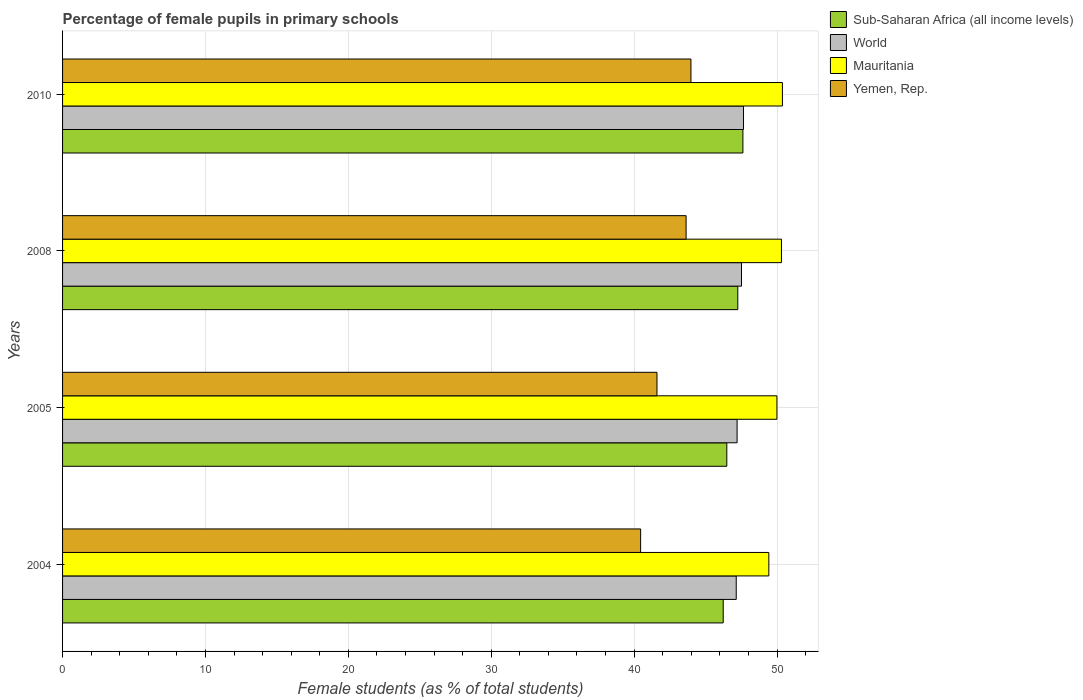How many groups of bars are there?
Provide a succinct answer. 4. Are the number of bars per tick equal to the number of legend labels?
Ensure brevity in your answer.  Yes. Are the number of bars on each tick of the Y-axis equal?
Provide a short and direct response. Yes. How many bars are there on the 2nd tick from the bottom?
Provide a succinct answer. 4. In how many cases, is the number of bars for a given year not equal to the number of legend labels?
Ensure brevity in your answer.  0. What is the percentage of female pupils in primary schools in Mauritania in 2008?
Keep it short and to the point. 50.31. Across all years, what is the maximum percentage of female pupils in primary schools in Mauritania?
Keep it short and to the point. 50.38. Across all years, what is the minimum percentage of female pupils in primary schools in Mauritania?
Give a very brief answer. 49.43. In which year was the percentage of female pupils in primary schools in Yemen, Rep. minimum?
Your response must be concise. 2004. What is the total percentage of female pupils in primary schools in Yemen, Rep. in the graph?
Ensure brevity in your answer.  169.67. What is the difference between the percentage of female pupils in primary schools in Yemen, Rep. in 2005 and that in 2010?
Keep it short and to the point. -2.38. What is the difference between the percentage of female pupils in primary schools in Sub-Saharan Africa (all income levels) in 2004 and the percentage of female pupils in primary schools in World in 2005?
Give a very brief answer. -0.97. What is the average percentage of female pupils in primary schools in World per year?
Your response must be concise. 47.38. In the year 2008, what is the difference between the percentage of female pupils in primary schools in Yemen, Rep. and percentage of female pupils in primary schools in Mauritania?
Offer a terse response. -6.67. What is the ratio of the percentage of female pupils in primary schools in Mauritania in 2004 to that in 2010?
Give a very brief answer. 0.98. Is the percentage of female pupils in primary schools in Yemen, Rep. in 2005 less than that in 2008?
Make the answer very short. Yes. What is the difference between the highest and the second highest percentage of female pupils in primary schools in Mauritania?
Give a very brief answer. 0.07. What is the difference between the highest and the lowest percentage of female pupils in primary schools in Sub-Saharan Africa (all income levels)?
Your response must be concise. 1.38. What does the 4th bar from the top in 2005 represents?
Your response must be concise. Sub-Saharan Africa (all income levels). What does the 2nd bar from the bottom in 2008 represents?
Provide a succinct answer. World. How many bars are there?
Offer a terse response. 16. How many years are there in the graph?
Offer a very short reply. 4. Are the values on the major ticks of X-axis written in scientific E-notation?
Provide a short and direct response. No. Does the graph contain any zero values?
Provide a short and direct response. No. Does the graph contain grids?
Give a very brief answer. Yes. Where does the legend appear in the graph?
Offer a terse response. Top right. How many legend labels are there?
Your answer should be compact. 4. What is the title of the graph?
Offer a terse response. Percentage of female pupils in primary schools. What is the label or title of the X-axis?
Your response must be concise. Female students (as % of total students). What is the label or title of the Y-axis?
Your answer should be compact. Years. What is the Female students (as % of total students) of Sub-Saharan Africa (all income levels) in 2004?
Your answer should be compact. 46.23. What is the Female students (as % of total students) of World in 2004?
Make the answer very short. 47.15. What is the Female students (as % of total students) of Mauritania in 2004?
Make the answer very short. 49.43. What is the Female students (as % of total students) in Yemen, Rep. in 2004?
Provide a short and direct response. 40.45. What is the Female students (as % of total students) in Sub-Saharan Africa (all income levels) in 2005?
Your response must be concise. 46.49. What is the Female students (as % of total students) in World in 2005?
Keep it short and to the point. 47.21. What is the Female students (as % of total students) of Mauritania in 2005?
Your response must be concise. 49.99. What is the Female students (as % of total students) in Yemen, Rep. in 2005?
Offer a terse response. 41.6. What is the Female students (as % of total students) in Sub-Saharan Africa (all income levels) in 2008?
Provide a succinct answer. 47.26. What is the Female students (as % of total students) of World in 2008?
Offer a terse response. 47.52. What is the Female students (as % of total students) of Mauritania in 2008?
Make the answer very short. 50.31. What is the Female students (as % of total students) of Yemen, Rep. in 2008?
Your answer should be very brief. 43.64. What is the Female students (as % of total students) in Sub-Saharan Africa (all income levels) in 2010?
Provide a short and direct response. 47.61. What is the Female students (as % of total students) of World in 2010?
Offer a very short reply. 47.66. What is the Female students (as % of total students) of Mauritania in 2010?
Ensure brevity in your answer.  50.38. What is the Female students (as % of total students) of Yemen, Rep. in 2010?
Keep it short and to the point. 43.98. Across all years, what is the maximum Female students (as % of total students) of Sub-Saharan Africa (all income levels)?
Your answer should be very brief. 47.61. Across all years, what is the maximum Female students (as % of total students) in World?
Offer a terse response. 47.66. Across all years, what is the maximum Female students (as % of total students) in Mauritania?
Your answer should be compact. 50.38. Across all years, what is the maximum Female students (as % of total students) in Yemen, Rep.?
Keep it short and to the point. 43.98. Across all years, what is the minimum Female students (as % of total students) in Sub-Saharan Africa (all income levels)?
Give a very brief answer. 46.23. Across all years, what is the minimum Female students (as % of total students) of World?
Provide a short and direct response. 47.15. Across all years, what is the minimum Female students (as % of total students) in Mauritania?
Provide a succinct answer. 49.43. Across all years, what is the minimum Female students (as % of total students) in Yemen, Rep.?
Provide a short and direct response. 40.45. What is the total Female students (as % of total students) in Sub-Saharan Africa (all income levels) in the graph?
Keep it short and to the point. 187.59. What is the total Female students (as % of total students) in World in the graph?
Your answer should be compact. 189.52. What is the total Female students (as % of total students) in Mauritania in the graph?
Make the answer very short. 200.11. What is the total Female students (as % of total students) of Yemen, Rep. in the graph?
Keep it short and to the point. 169.67. What is the difference between the Female students (as % of total students) of Sub-Saharan Africa (all income levels) in 2004 and that in 2005?
Your answer should be very brief. -0.25. What is the difference between the Female students (as % of total students) of World in 2004 and that in 2005?
Keep it short and to the point. -0.06. What is the difference between the Female students (as % of total students) of Mauritania in 2004 and that in 2005?
Keep it short and to the point. -0.57. What is the difference between the Female students (as % of total students) of Yemen, Rep. in 2004 and that in 2005?
Offer a very short reply. -1.14. What is the difference between the Female students (as % of total students) of Sub-Saharan Africa (all income levels) in 2004 and that in 2008?
Provide a succinct answer. -1.02. What is the difference between the Female students (as % of total students) in World in 2004 and that in 2008?
Your answer should be very brief. -0.37. What is the difference between the Female students (as % of total students) of Mauritania in 2004 and that in 2008?
Give a very brief answer. -0.88. What is the difference between the Female students (as % of total students) of Yemen, Rep. in 2004 and that in 2008?
Your response must be concise. -3.18. What is the difference between the Female students (as % of total students) in Sub-Saharan Africa (all income levels) in 2004 and that in 2010?
Your response must be concise. -1.38. What is the difference between the Female students (as % of total students) of World in 2004 and that in 2010?
Ensure brevity in your answer.  -0.51. What is the difference between the Female students (as % of total students) of Mauritania in 2004 and that in 2010?
Keep it short and to the point. -0.95. What is the difference between the Female students (as % of total students) of Yemen, Rep. in 2004 and that in 2010?
Your answer should be very brief. -3.52. What is the difference between the Female students (as % of total students) of Sub-Saharan Africa (all income levels) in 2005 and that in 2008?
Your answer should be very brief. -0.77. What is the difference between the Female students (as % of total students) of World in 2005 and that in 2008?
Provide a short and direct response. -0.31. What is the difference between the Female students (as % of total students) of Mauritania in 2005 and that in 2008?
Keep it short and to the point. -0.32. What is the difference between the Female students (as % of total students) in Yemen, Rep. in 2005 and that in 2008?
Your response must be concise. -2.04. What is the difference between the Female students (as % of total students) in Sub-Saharan Africa (all income levels) in 2005 and that in 2010?
Ensure brevity in your answer.  -1.13. What is the difference between the Female students (as % of total students) of World in 2005 and that in 2010?
Provide a short and direct response. -0.45. What is the difference between the Female students (as % of total students) in Mauritania in 2005 and that in 2010?
Provide a short and direct response. -0.39. What is the difference between the Female students (as % of total students) in Yemen, Rep. in 2005 and that in 2010?
Your answer should be compact. -2.38. What is the difference between the Female students (as % of total students) of Sub-Saharan Africa (all income levels) in 2008 and that in 2010?
Make the answer very short. -0.36. What is the difference between the Female students (as % of total students) in World in 2008 and that in 2010?
Your answer should be very brief. -0.14. What is the difference between the Female students (as % of total students) of Mauritania in 2008 and that in 2010?
Your response must be concise. -0.07. What is the difference between the Female students (as % of total students) in Yemen, Rep. in 2008 and that in 2010?
Provide a succinct answer. -0.34. What is the difference between the Female students (as % of total students) in Sub-Saharan Africa (all income levels) in 2004 and the Female students (as % of total students) in World in 2005?
Keep it short and to the point. -0.97. What is the difference between the Female students (as % of total students) of Sub-Saharan Africa (all income levels) in 2004 and the Female students (as % of total students) of Mauritania in 2005?
Give a very brief answer. -3.76. What is the difference between the Female students (as % of total students) in Sub-Saharan Africa (all income levels) in 2004 and the Female students (as % of total students) in Yemen, Rep. in 2005?
Provide a short and direct response. 4.64. What is the difference between the Female students (as % of total students) of World in 2004 and the Female students (as % of total students) of Mauritania in 2005?
Make the answer very short. -2.85. What is the difference between the Female students (as % of total students) in World in 2004 and the Female students (as % of total students) in Yemen, Rep. in 2005?
Keep it short and to the point. 5.55. What is the difference between the Female students (as % of total students) in Mauritania in 2004 and the Female students (as % of total students) in Yemen, Rep. in 2005?
Your response must be concise. 7.83. What is the difference between the Female students (as % of total students) of Sub-Saharan Africa (all income levels) in 2004 and the Female students (as % of total students) of World in 2008?
Offer a terse response. -1.28. What is the difference between the Female students (as % of total students) in Sub-Saharan Africa (all income levels) in 2004 and the Female students (as % of total students) in Mauritania in 2008?
Your answer should be very brief. -4.08. What is the difference between the Female students (as % of total students) in Sub-Saharan Africa (all income levels) in 2004 and the Female students (as % of total students) in Yemen, Rep. in 2008?
Provide a succinct answer. 2.6. What is the difference between the Female students (as % of total students) in World in 2004 and the Female students (as % of total students) in Mauritania in 2008?
Your answer should be compact. -3.17. What is the difference between the Female students (as % of total students) of World in 2004 and the Female students (as % of total students) of Yemen, Rep. in 2008?
Your answer should be compact. 3.51. What is the difference between the Female students (as % of total students) in Mauritania in 2004 and the Female students (as % of total students) in Yemen, Rep. in 2008?
Make the answer very short. 5.79. What is the difference between the Female students (as % of total students) in Sub-Saharan Africa (all income levels) in 2004 and the Female students (as % of total students) in World in 2010?
Give a very brief answer. -1.42. What is the difference between the Female students (as % of total students) in Sub-Saharan Africa (all income levels) in 2004 and the Female students (as % of total students) in Mauritania in 2010?
Ensure brevity in your answer.  -4.14. What is the difference between the Female students (as % of total students) of Sub-Saharan Africa (all income levels) in 2004 and the Female students (as % of total students) of Yemen, Rep. in 2010?
Give a very brief answer. 2.26. What is the difference between the Female students (as % of total students) in World in 2004 and the Female students (as % of total students) in Mauritania in 2010?
Offer a very short reply. -3.23. What is the difference between the Female students (as % of total students) in World in 2004 and the Female students (as % of total students) in Yemen, Rep. in 2010?
Provide a short and direct response. 3.17. What is the difference between the Female students (as % of total students) of Mauritania in 2004 and the Female students (as % of total students) of Yemen, Rep. in 2010?
Make the answer very short. 5.45. What is the difference between the Female students (as % of total students) of Sub-Saharan Africa (all income levels) in 2005 and the Female students (as % of total students) of World in 2008?
Give a very brief answer. -1.03. What is the difference between the Female students (as % of total students) in Sub-Saharan Africa (all income levels) in 2005 and the Female students (as % of total students) in Mauritania in 2008?
Ensure brevity in your answer.  -3.82. What is the difference between the Female students (as % of total students) of Sub-Saharan Africa (all income levels) in 2005 and the Female students (as % of total students) of Yemen, Rep. in 2008?
Your response must be concise. 2.85. What is the difference between the Female students (as % of total students) of World in 2005 and the Female students (as % of total students) of Mauritania in 2008?
Offer a terse response. -3.1. What is the difference between the Female students (as % of total students) in World in 2005 and the Female students (as % of total students) in Yemen, Rep. in 2008?
Make the answer very short. 3.57. What is the difference between the Female students (as % of total students) in Mauritania in 2005 and the Female students (as % of total students) in Yemen, Rep. in 2008?
Provide a succinct answer. 6.35. What is the difference between the Female students (as % of total students) of Sub-Saharan Africa (all income levels) in 2005 and the Female students (as % of total students) of World in 2010?
Give a very brief answer. -1.17. What is the difference between the Female students (as % of total students) in Sub-Saharan Africa (all income levels) in 2005 and the Female students (as % of total students) in Mauritania in 2010?
Your answer should be very brief. -3.89. What is the difference between the Female students (as % of total students) in Sub-Saharan Africa (all income levels) in 2005 and the Female students (as % of total students) in Yemen, Rep. in 2010?
Your answer should be compact. 2.51. What is the difference between the Female students (as % of total students) in World in 2005 and the Female students (as % of total students) in Mauritania in 2010?
Your answer should be very brief. -3.17. What is the difference between the Female students (as % of total students) of World in 2005 and the Female students (as % of total students) of Yemen, Rep. in 2010?
Keep it short and to the point. 3.23. What is the difference between the Female students (as % of total students) of Mauritania in 2005 and the Female students (as % of total students) of Yemen, Rep. in 2010?
Keep it short and to the point. 6.02. What is the difference between the Female students (as % of total students) of Sub-Saharan Africa (all income levels) in 2008 and the Female students (as % of total students) of World in 2010?
Give a very brief answer. -0.4. What is the difference between the Female students (as % of total students) in Sub-Saharan Africa (all income levels) in 2008 and the Female students (as % of total students) in Mauritania in 2010?
Your answer should be compact. -3.12. What is the difference between the Female students (as % of total students) in Sub-Saharan Africa (all income levels) in 2008 and the Female students (as % of total students) in Yemen, Rep. in 2010?
Provide a short and direct response. 3.28. What is the difference between the Female students (as % of total students) of World in 2008 and the Female students (as % of total students) of Mauritania in 2010?
Provide a succinct answer. -2.86. What is the difference between the Female students (as % of total students) in World in 2008 and the Female students (as % of total students) in Yemen, Rep. in 2010?
Your response must be concise. 3.54. What is the difference between the Female students (as % of total students) of Mauritania in 2008 and the Female students (as % of total students) of Yemen, Rep. in 2010?
Your response must be concise. 6.34. What is the average Female students (as % of total students) of Sub-Saharan Africa (all income levels) per year?
Offer a very short reply. 46.9. What is the average Female students (as % of total students) of World per year?
Your response must be concise. 47.38. What is the average Female students (as % of total students) of Mauritania per year?
Your response must be concise. 50.03. What is the average Female students (as % of total students) of Yemen, Rep. per year?
Ensure brevity in your answer.  42.42. In the year 2004, what is the difference between the Female students (as % of total students) in Sub-Saharan Africa (all income levels) and Female students (as % of total students) in World?
Offer a very short reply. -0.91. In the year 2004, what is the difference between the Female students (as % of total students) in Sub-Saharan Africa (all income levels) and Female students (as % of total students) in Mauritania?
Give a very brief answer. -3.19. In the year 2004, what is the difference between the Female students (as % of total students) of Sub-Saharan Africa (all income levels) and Female students (as % of total students) of Yemen, Rep.?
Make the answer very short. 5.78. In the year 2004, what is the difference between the Female students (as % of total students) in World and Female students (as % of total students) in Mauritania?
Provide a succinct answer. -2.28. In the year 2004, what is the difference between the Female students (as % of total students) in World and Female students (as % of total students) in Yemen, Rep.?
Offer a very short reply. 6.69. In the year 2004, what is the difference between the Female students (as % of total students) in Mauritania and Female students (as % of total students) in Yemen, Rep.?
Offer a very short reply. 8.97. In the year 2005, what is the difference between the Female students (as % of total students) in Sub-Saharan Africa (all income levels) and Female students (as % of total students) in World?
Provide a short and direct response. -0.72. In the year 2005, what is the difference between the Female students (as % of total students) in Sub-Saharan Africa (all income levels) and Female students (as % of total students) in Mauritania?
Give a very brief answer. -3.51. In the year 2005, what is the difference between the Female students (as % of total students) of Sub-Saharan Africa (all income levels) and Female students (as % of total students) of Yemen, Rep.?
Your answer should be compact. 4.89. In the year 2005, what is the difference between the Female students (as % of total students) of World and Female students (as % of total students) of Mauritania?
Keep it short and to the point. -2.79. In the year 2005, what is the difference between the Female students (as % of total students) of World and Female students (as % of total students) of Yemen, Rep.?
Your answer should be very brief. 5.61. In the year 2005, what is the difference between the Female students (as % of total students) of Mauritania and Female students (as % of total students) of Yemen, Rep.?
Your response must be concise. 8.39. In the year 2008, what is the difference between the Female students (as % of total students) of Sub-Saharan Africa (all income levels) and Female students (as % of total students) of World?
Give a very brief answer. -0.26. In the year 2008, what is the difference between the Female students (as % of total students) in Sub-Saharan Africa (all income levels) and Female students (as % of total students) in Mauritania?
Provide a short and direct response. -3.06. In the year 2008, what is the difference between the Female students (as % of total students) in Sub-Saharan Africa (all income levels) and Female students (as % of total students) in Yemen, Rep.?
Provide a short and direct response. 3.62. In the year 2008, what is the difference between the Female students (as % of total students) of World and Female students (as % of total students) of Mauritania?
Ensure brevity in your answer.  -2.79. In the year 2008, what is the difference between the Female students (as % of total students) in World and Female students (as % of total students) in Yemen, Rep.?
Offer a terse response. 3.88. In the year 2008, what is the difference between the Female students (as % of total students) of Mauritania and Female students (as % of total students) of Yemen, Rep.?
Keep it short and to the point. 6.67. In the year 2010, what is the difference between the Female students (as % of total students) in Sub-Saharan Africa (all income levels) and Female students (as % of total students) in World?
Your answer should be compact. -0.04. In the year 2010, what is the difference between the Female students (as % of total students) in Sub-Saharan Africa (all income levels) and Female students (as % of total students) in Mauritania?
Give a very brief answer. -2.77. In the year 2010, what is the difference between the Female students (as % of total students) of Sub-Saharan Africa (all income levels) and Female students (as % of total students) of Yemen, Rep.?
Your answer should be very brief. 3.64. In the year 2010, what is the difference between the Female students (as % of total students) in World and Female students (as % of total students) in Mauritania?
Keep it short and to the point. -2.72. In the year 2010, what is the difference between the Female students (as % of total students) of World and Female students (as % of total students) of Yemen, Rep.?
Offer a very short reply. 3.68. In the year 2010, what is the difference between the Female students (as % of total students) of Mauritania and Female students (as % of total students) of Yemen, Rep.?
Make the answer very short. 6.4. What is the ratio of the Female students (as % of total students) of Mauritania in 2004 to that in 2005?
Provide a succinct answer. 0.99. What is the ratio of the Female students (as % of total students) of Yemen, Rep. in 2004 to that in 2005?
Offer a very short reply. 0.97. What is the ratio of the Female students (as % of total students) in Sub-Saharan Africa (all income levels) in 2004 to that in 2008?
Give a very brief answer. 0.98. What is the ratio of the Female students (as % of total students) in Mauritania in 2004 to that in 2008?
Your response must be concise. 0.98. What is the ratio of the Female students (as % of total students) in Yemen, Rep. in 2004 to that in 2008?
Ensure brevity in your answer.  0.93. What is the ratio of the Female students (as % of total students) of Sub-Saharan Africa (all income levels) in 2004 to that in 2010?
Offer a very short reply. 0.97. What is the ratio of the Female students (as % of total students) in World in 2004 to that in 2010?
Your answer should be compact. 0.99. What is the ratio of the Female students (as % of total students) of Mauritania in 2004 to that in 2010?
Provide a short and direct response. 0.98. What is the ratio of the Female students (as % of total students) in Yemen, Rep. in 2004 to that in 2010?
Make the answer very short. 0.92. What is the ratio of the Female students (as % of total students) in Sub-Saharan Africa (all income levels) in 2005 to that in 2008?
Provide a succinct answer. 0.98. What is the ratio of the Female students (as % of total students) in World in 2005 to that in 2008?
Give a very brief answer. 0.99. What is the ratio of the Female students (as % of total students) of Mauritania in 2005 to that in 2008?
Offer a terse response. 0.99. What is the ratio of the Female students (as % of total students) of Yemen, Rep. in 2005 to that in 2008?
Make the answer very short. 0.95. What is the ratio of the Female students (as % of total students) in Sub-Saharan Africa (all income levels) in 2005 to that in 2010?
Offer a very short reply. 0.98. What is the ratio of the Female students (as % of total students) of World in 2005 to that in 2010?
Provide a short and direct response. 0.99. What is the ratio of the Female students (as % of total students) of Mauritania in 2005 to that in 2010?
Your response must be concise. 0.99. What is the ratio of the Female students (as % of total students) of Yemen, Rep. in 2005 to that in 2010?
Your response must be concise. 0.95. What is the ratio of the Female students (as % of total students) of World in 2008 to that in 2010?
Keep it short and to the point. 1. What is the ratio of the Female students (as % of total students) of Yemen, Rep. in 2008 to that in 2010?
Provide a short and direct response. 0.99. What is the difference between the highest and the second highest Female students (as % of total students) of Sub-Saharan Africa (all income levels)?
Your answer should be compact. 0.36. What is the difference between the highest and the second highest Female students (as % of total students) in World?
Your answer should be very brief. 0.14. What is the difference between the highest and the second highest Female students (as % of total students) in Mauritania?
Give a very brief answer. 0.07. What is the difference between the highest and the second highest Female students (as % of total students) of Yemen, Rep.?
Offer a very short reply. 0.34. What is the difference between the highest and the lowest Female students (as % of total students) of Sub-Saharan Africa (all income levels)?
Keep it short and to the point. 1.38. What is the difference between the highest and the lowest Female students (as % of total students) in World?
Offer a very short reply. 0.51. What is the difference between the highest and the lowest Female students (as % of total students) in Mauritania?
Offer a terse response. 0.95. What is the difference between the highest and the lowest Female students (as % of total students) of Yemen, Rep.?
Keep it short and to the point. 3.52. 